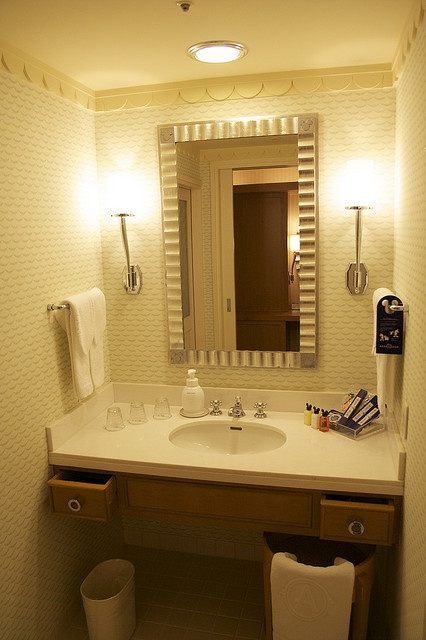Describe the objects in this image and their specific colors. I can see sink in olive and tan tones, bottle in olive and tan tones, cup in olive and tan tones, cup in olive and tan tones, and cup in olive and tan tones in this image. 